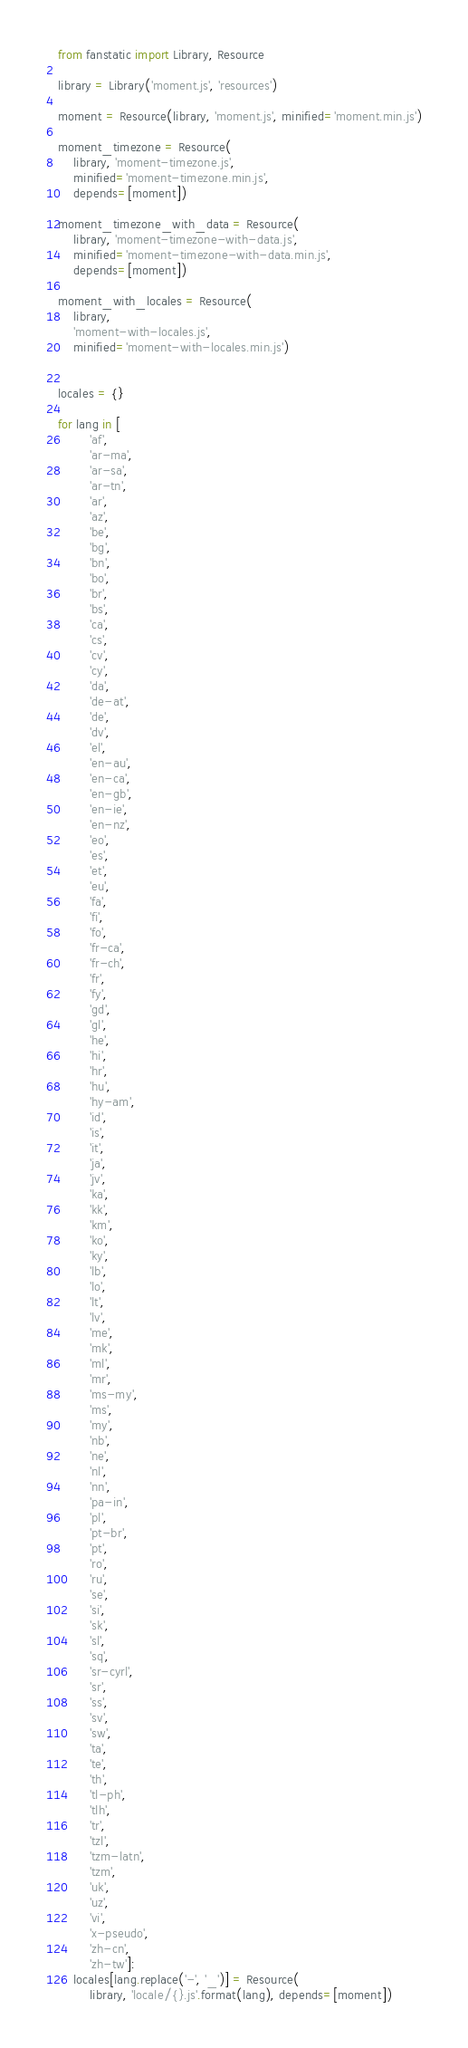<code> <loc_0><loc_0><loc_500><loc_500><_Python_>from fanstatic import Library, Resource

library = Library('moment.js', 'resources')

moment = Resource(library, 'moment.js', minified='moment.min.js')

moment_timezone = Resource(
    library, 'moment-timezone.js',
    minified='moment-timezone.min.js',
    depends=[moment])

moment_timezone_with_data = Resource(
    library, 'moment-timezone-with-data.js',
    minified='moment-timezone-with-data.min.js',
    depends=[moment])

moment_with_locales = Resource(
    library,
    'moment-with-locales.js',
    minified='moment-with-locales.min.js')


locales = {}

for lang in [
        'af',
        'ar-ma',
        'ar-sa',
        'ar-tn',
        'ar',
        'az',
        'be',
        'bg',
        'bn',
        'bo',
        'br',
        'bs',
        'ca',
        'cs',
        'cv',
        'cy',
        'da',
        'de-at',
        'de',
        'dv',
        'el',
        'en-au',
        'en-ca',
        'en-gb',
        'en-ie',
        'en-nz',
        'eo',
        'es',
        'et',
        'eu',
        'fa',
        'fi',
        'fo',
        'fr-ca',
        'fr-ch',
        'fr',
        'fy',
        'gd',
        'gl',
        'he',
        'hi',
        'hr',
        'hu',
        'hy-am',
        'id',
        'is',
        'it',
        'ja',
        'jv',
        'ka',
        'kk',
        'km',
        'ko',
        'ky',
        'lb',
        'lo',
        'lt',
        'lv',
        'me',
        'mk',
        'ml',
        'mr',
        'ms-my',
        'ms',
        'my',
        'nb',
        'ne',
        'nl',
        'nn',
        'pa-in',
        'pl',
        'pt-br',
        'pt',
        'ro',
        'ru',
        'se',
        'si',
        'sk',
        'sl',
        'sq',
        'sr-cyrl',
        'sr',
        'ss',
        'sv',
        'sw',
        'ta',
        'te',
        'th',
        'tl-ph',
        'tlh',
        'tr',
        'tzl',
        'tzm-latn',
        'tzm',
        'uk',
        'uz',
        'vi',
        'x-pseudo',
        'zh-cn',
        'zh-tw']:
    locales[lang.replace('-', '_')] = Resource(
        library, 'locale/{}.js'.format(lang), depends=[moment])
</code> 